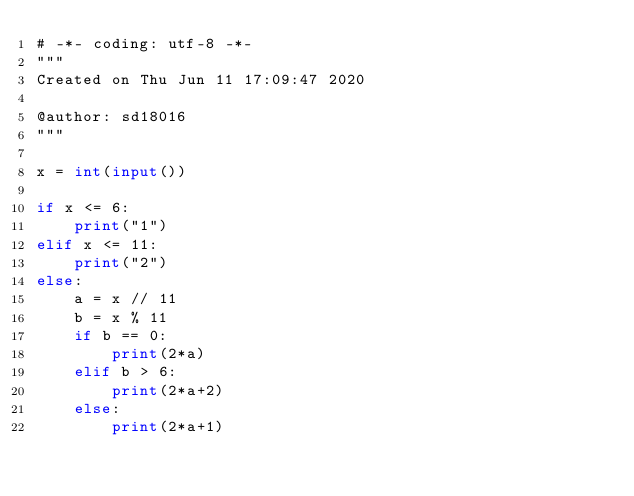<code> <loc_0><loc_0><loc_500><loc_500><_Python_># -*- coding: utf-8 -*-
"""
Created on Thu Jun 11 17:09:47 2020

@author: sd18016
"""   

x = int(input())

if x <= 6:
    print("1")
elif x <= 11:
    print("2")
else:
    a = x // 11
    b = x % 11
    if b == 0:
        print(2*a)
    elif b > 6:
        print(2*a+2)
    else:
        print(2*a+1)

</code> 